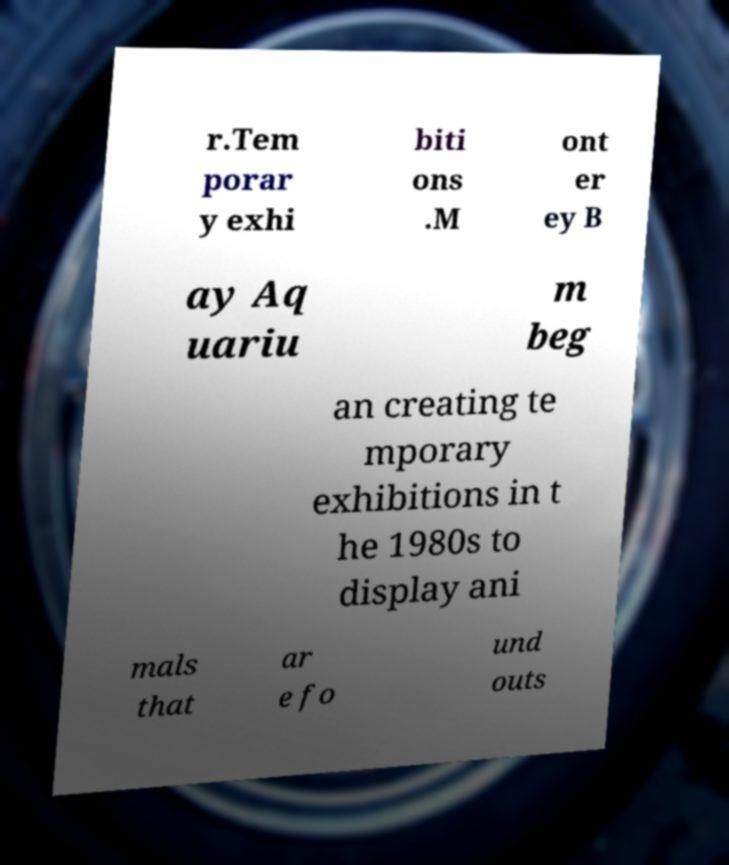Can you accurately transcribe the text from the provided image for me? r.Tem porar y exhi biti ons .M ont er ey B ay Aq uariu m beg an creating te mporary exhibitions in t he 1980s to display ani mals that ar e fo und outs 